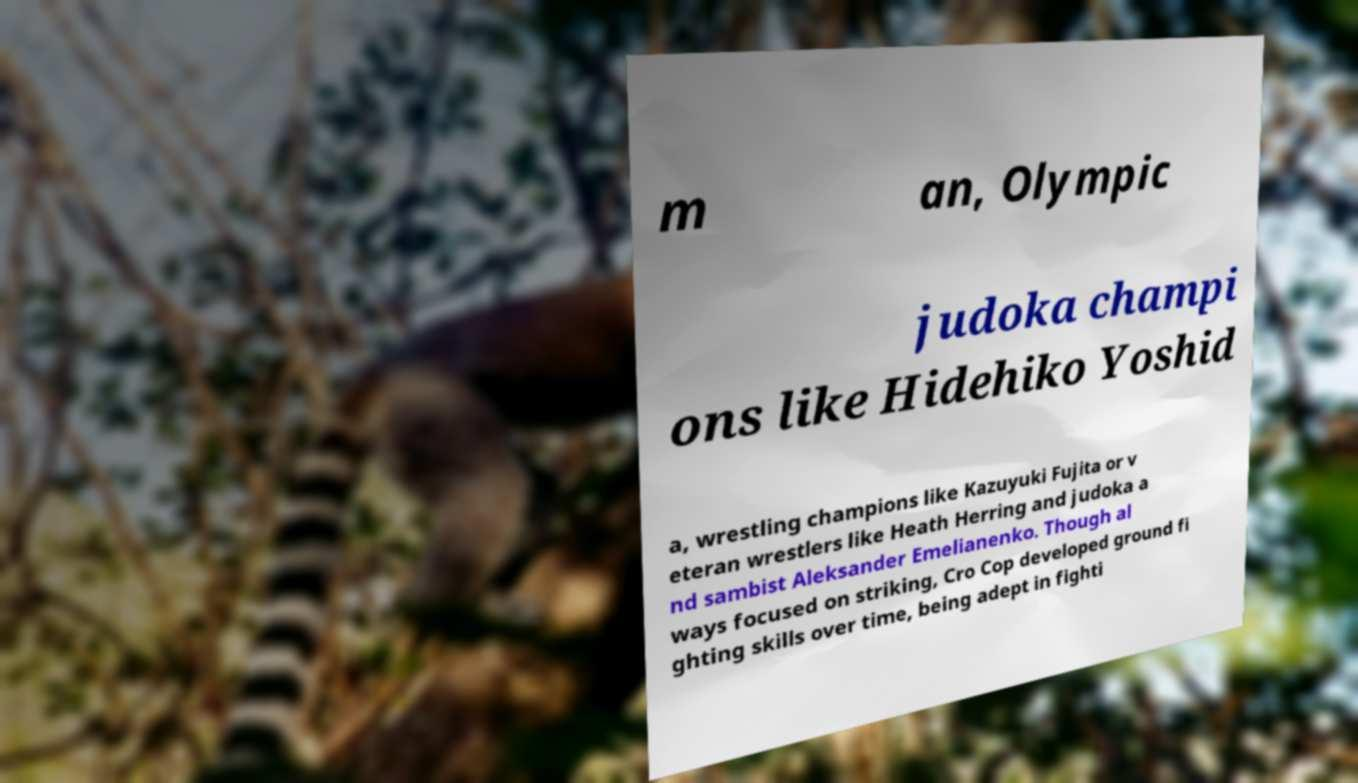Could you assist in decoding the text presented in this image and type it out clearly? m an, Olympic judoka champi ons like Hidehiko Yoshid a, wrestling champions like Kazuyuki Fujita or v eteran wrestlers like Heath Herring and judoka a nd sambist Aleksander Emelianenko. Though al ways focused on striking, Cro Cop developed ground fi ghting skills over time, being adept in fighti 